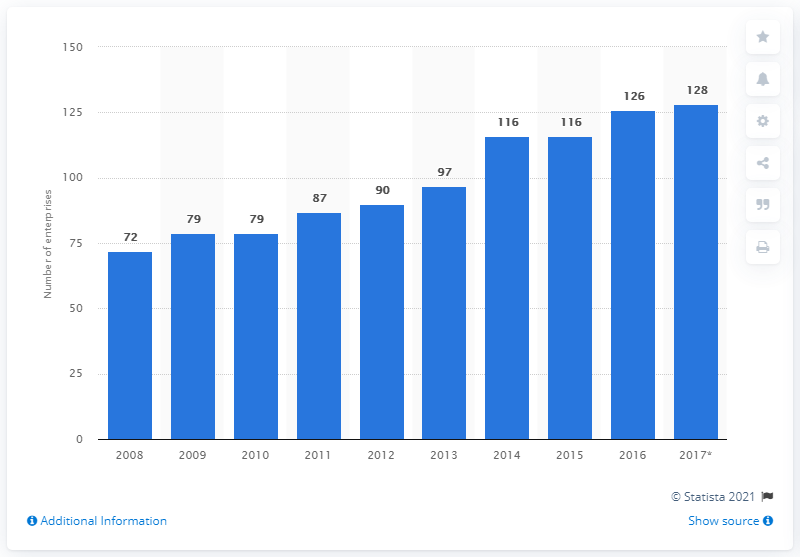Identify some key points in this picture. In 2017, there were 128 mining and quarrying enterprises operating in Lithuania. 